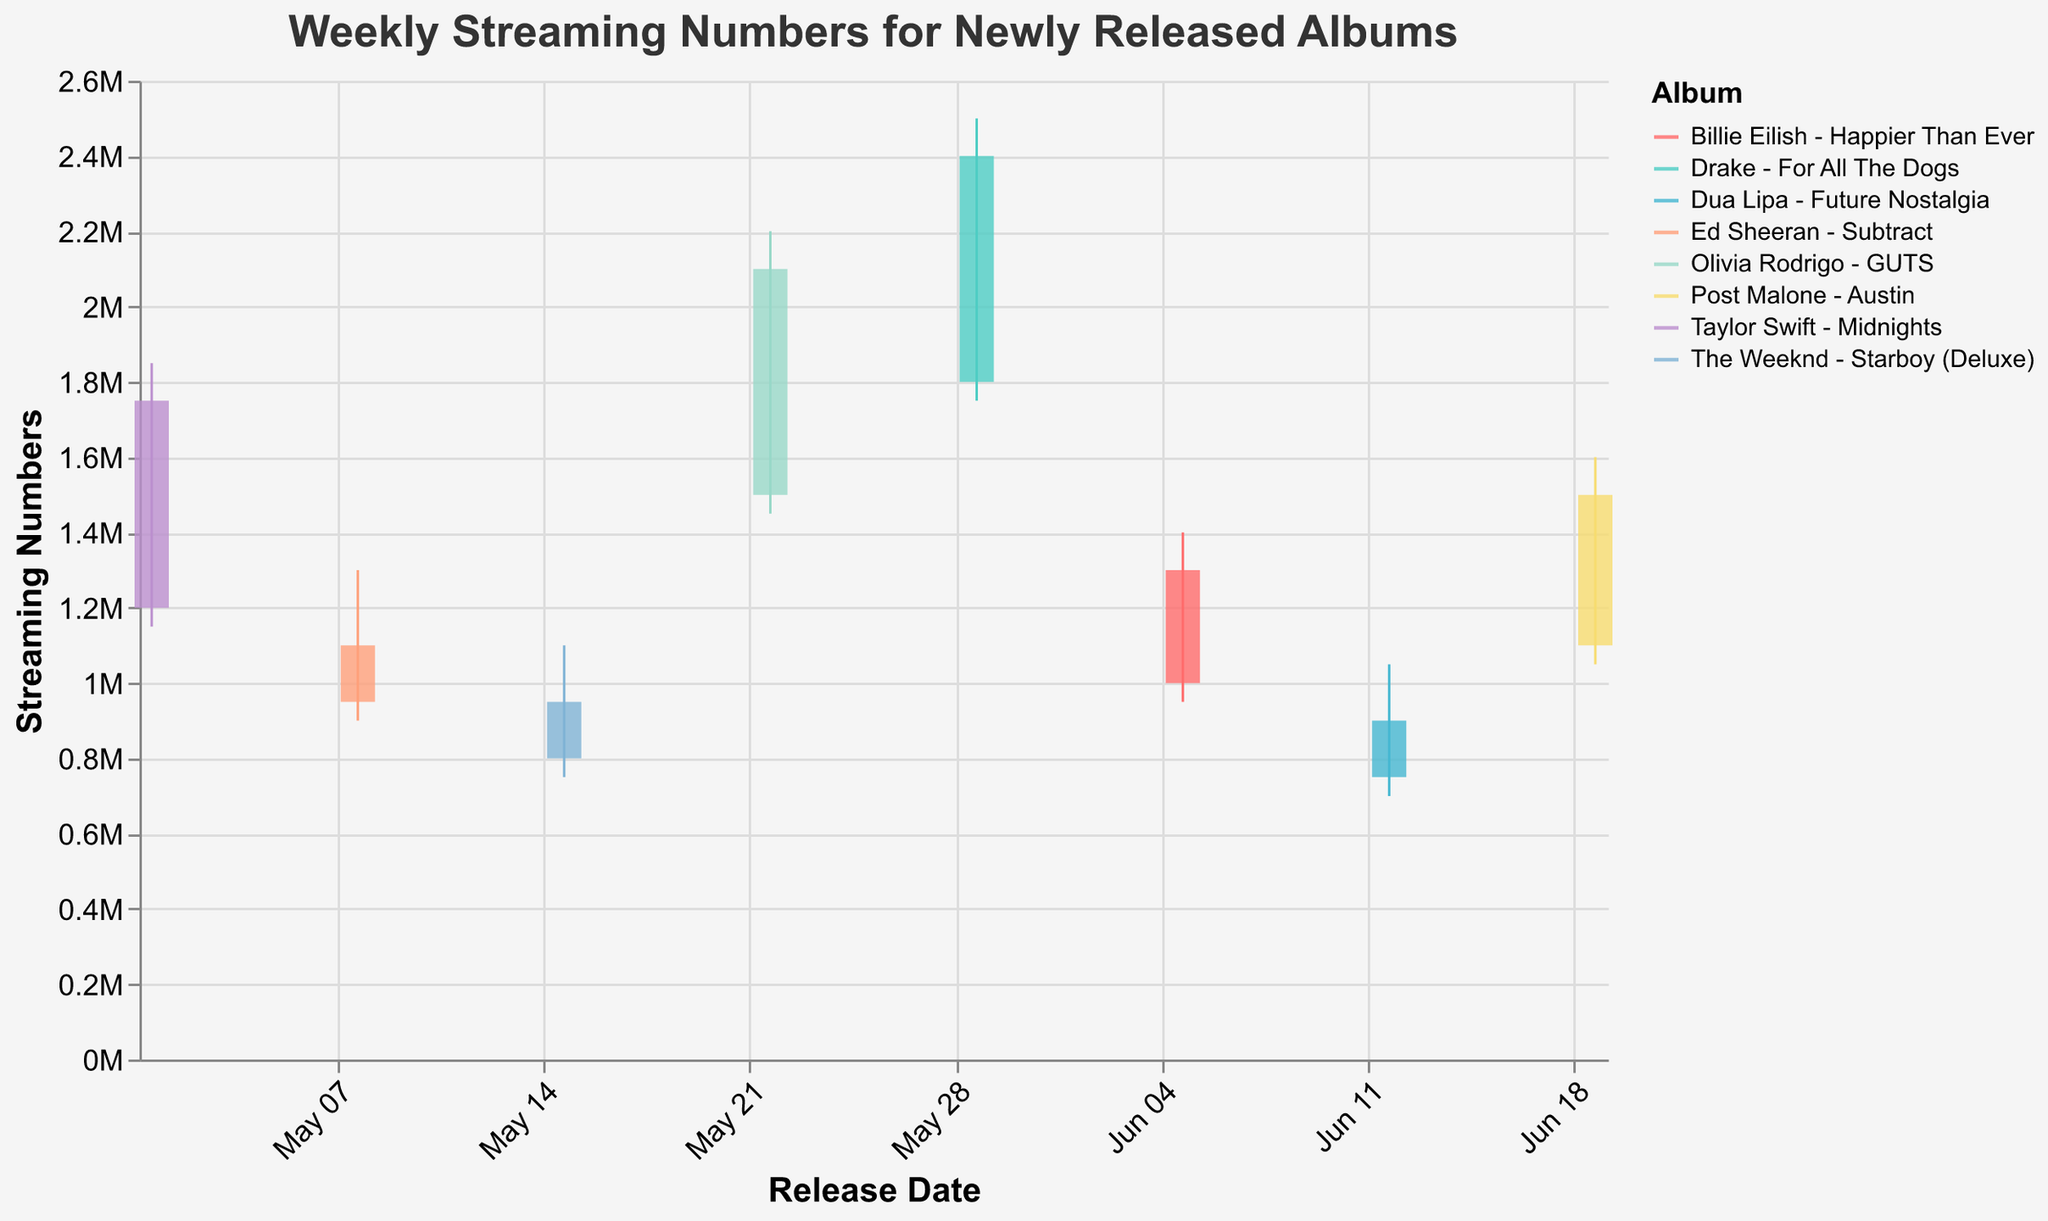What's the title of the figure? The title of the figure is displayed at the top of the chart in a larger font
Answer: Weekly Streaming Numbers for Newly Released Albums How many albums' weekly numbers are represented in the chart? Count the number of distinct albums listed in the dataset
Answer: 8 Which album had the highest streaming numbers in a week and what was the value? Identify the album with the highest "High" value
Answer: Drake - For All The Dogs with 2,500,000 streams Which album had the lowest opening streaming numbers and what was the value? Identify the album with the lowest "Open" value
Answer: Dua Lipa - Future Nostalgia with 750,000 streams What was the range in streaming numbers for Olivia Rodrigo's "GUTS"? Subtract the lowest value (Low) from the highest value (High) for Olivia Rodrigo's "GUTS"
Answer: 750,000 (2,200,000 - 1,450,000) Which album had the smallest change in streaming numbers between the opening and closing? Calculate the difference between Open and Close for each album and find the smallest difference
Answer: Ed Sheeran - Subtract with a 150,000 decrease (1,100,000 - 950,000) Which album showed the greatest increase in streaming numbers from the opening to the closing? Calculate the difference between Open and Close for each album and find the largest increase
Answer: Taylor Swift - Midnights with a 550,000 increase (1,750,000 - 1,200,000) Which week's album had the lowest lowest-low amongst the data and what was the value? Identify the week and album with the overall lowest "Low" value
Answer: Dua Lipa - Future Nostalgia on 2023-06-12 with 700,000 streams Comparing the total range of streaming numbers for The Weeknd's "Starboy (Deluxe)" and Billie Eilish's "Happier Than Ever", which had a larger range? Calculate the range for each album (High - Low) and compare the two
Answer: Billie Eilish's "Happier Than Ever" with a range of 450,000 (1,400,000 - 950,000), compared to 350,000 for The Weeknd's "Starboy (Deluxe)" (1,100,000 - 750,000) What trend can be observed from the closing values of the albums over time? Observe the move and compare the closing values over the weeks to determine a trend
Answer: The trend shows a general increase followed by minor fluctuations 